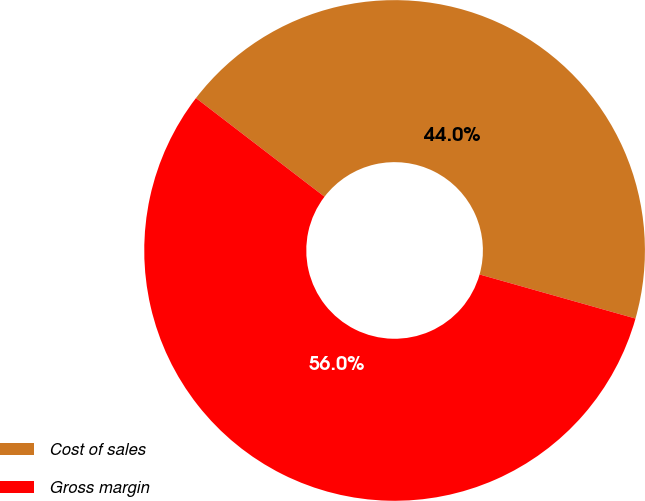<chart> <loc_0><loc_0><loc_500><loc_500><pie_chart><fcel>Cost of sales<fcel>Gross margin<nl><fcel>43.97%<fcel>56.03%<nl></chart> 